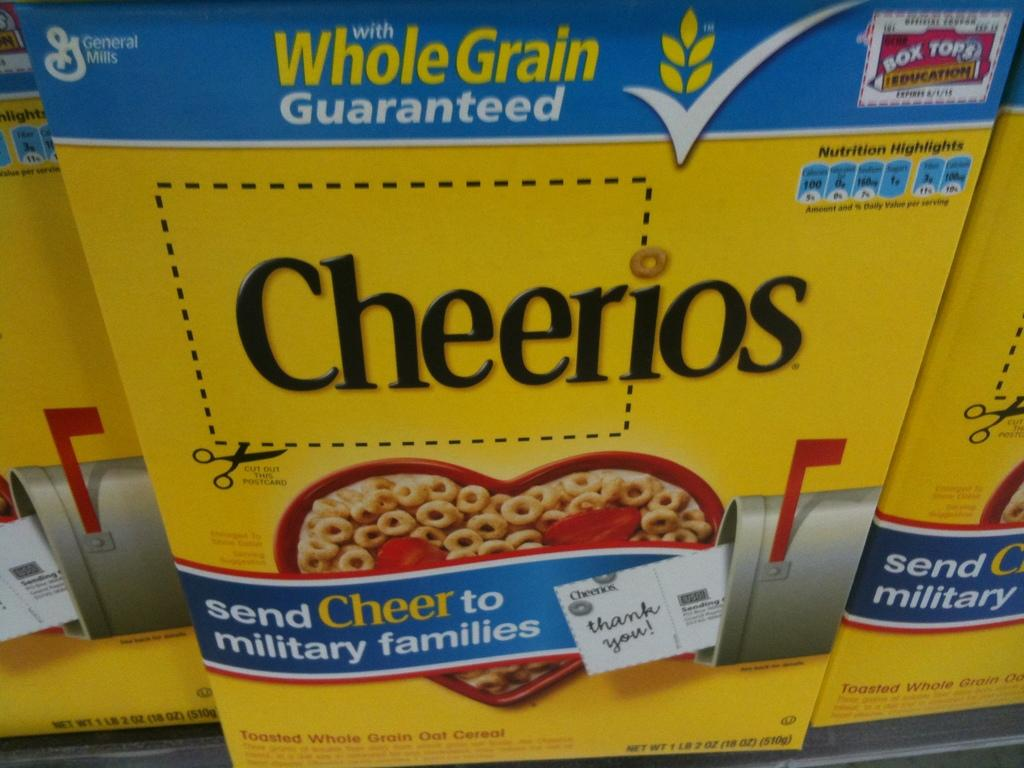<image>
Present a compact description of the photo's key features. A big yellow cheerios box that has a cutout outline on the logo. 